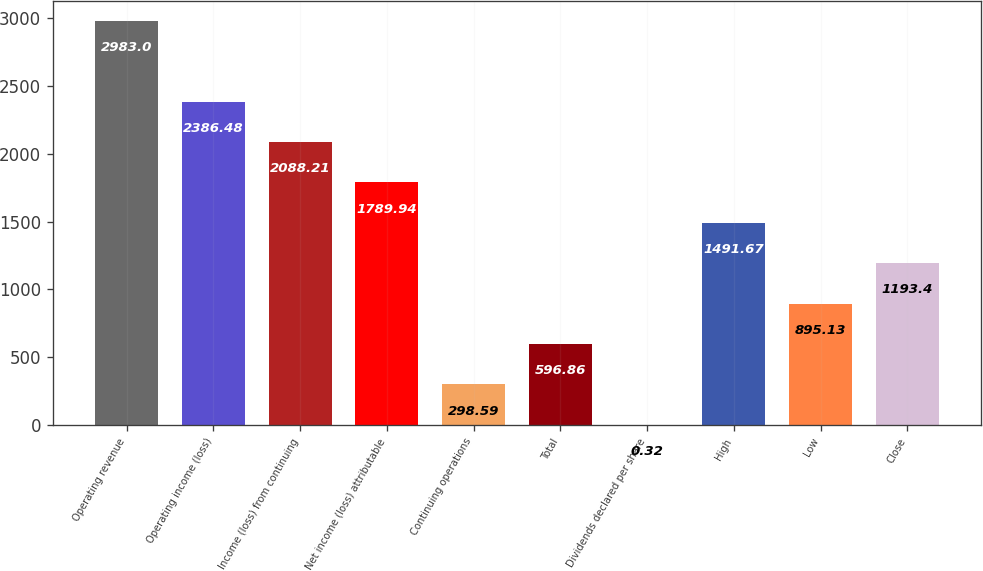Convert chart. <chart><loc_0><loc_0><loc_500><loc_500><bar_chart><fcel>Operating revenue<fcel>Operating income (loss)<fcel>Income (loss) from continuing<fcel>Net income (loss) attributable<fcel>Continuing operations<fcel>Total<fcel>Dividends declared per share<fcel>High<fcel>Low<fcel>Close<nl><fcel>2983<fcel>2386.48<fcel>2088.21<fcel>1789.94<fcel>298.59<fcel>596.86<fcel>0.32<fcel>1491.67<fcel>895.13<fcel>1193.4<nl></chart> 